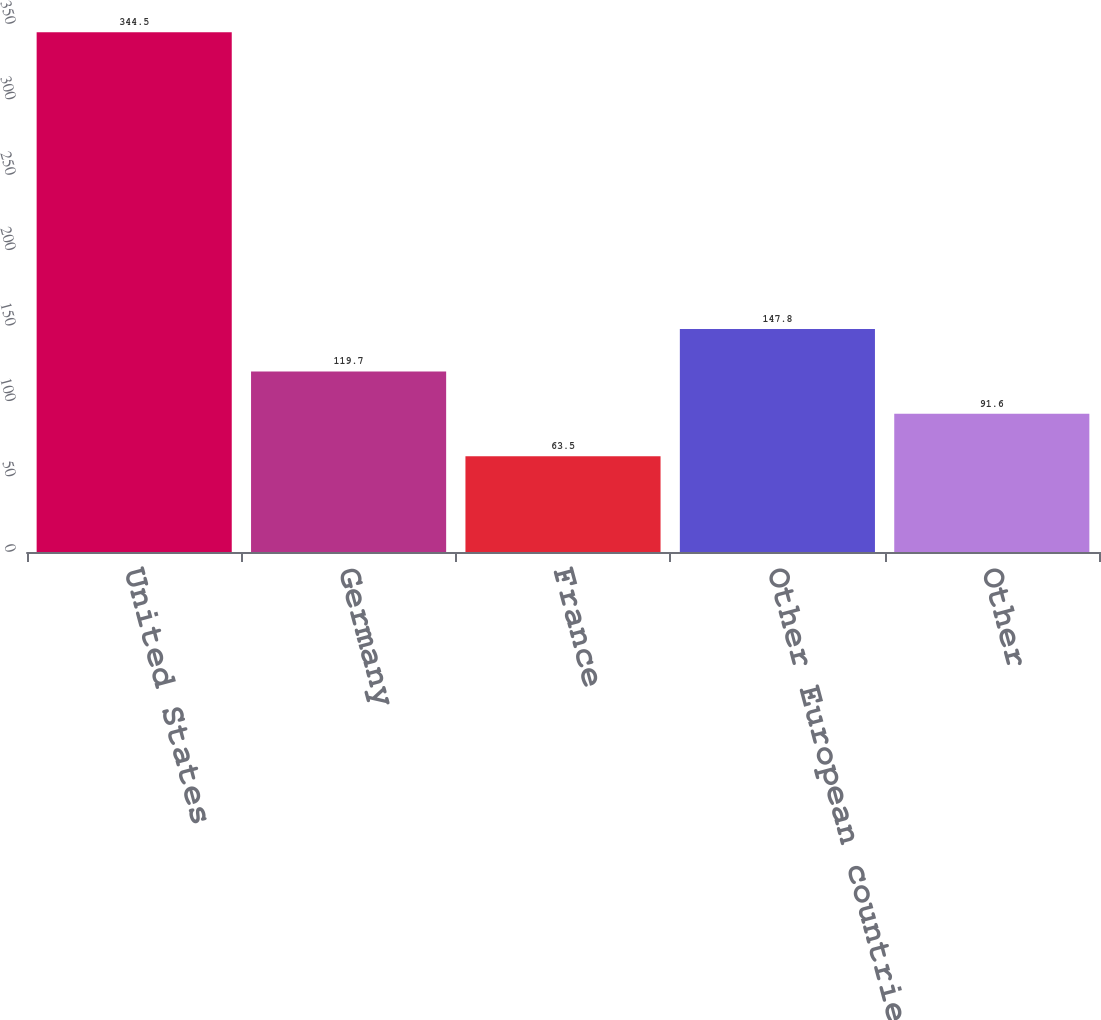<chart> <loc_0><loc_0><loc_500><loc_500><bar_chart><fcel>United States<fcel>Germany<fcel>France<fcel>Other European countries<fcel>Other<nl><fcel>344.5<fcel>119.7<fcel>63.5<fcel>147.8<fcel>91.6<nl></chart> 